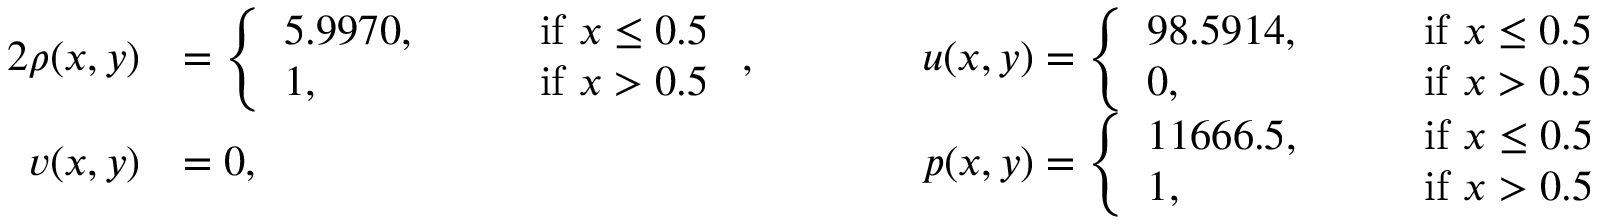Convert formula to latex. <formula><loc_0><loc_0><loc_500><loc_500>\begin{array} { r l r l } { { 2 } \rho ( x , y ) } & { = \left \{ \begin{array} { l l } { 5 . 9 9 7 0 , \quad } & { i f x \leq 0 . 5 } \\ { 1 , } & { i f x > 0 . 5 } \end{array} , \quad } & & { u ( x , y ) = \left \{ \begin{array} { l l } { 9 8 . 5 9 1 4 , \quad } & { i f x \leq 0 . 5 } \\ { 0 , } & { i f x > 0 . 5 } \end{array} } \\ { v ( x , y ) } & { = 0 , \quad } & & { p ( x , y ) = \left \{ \begin{array} { l l } { 1 1 6 6 6 . 5 , \quad } & { i f x \leq 0 . 5 } \\ { 1 , } & { i f x > 0 . 5 } \end{array} } \end{array}</formula> 